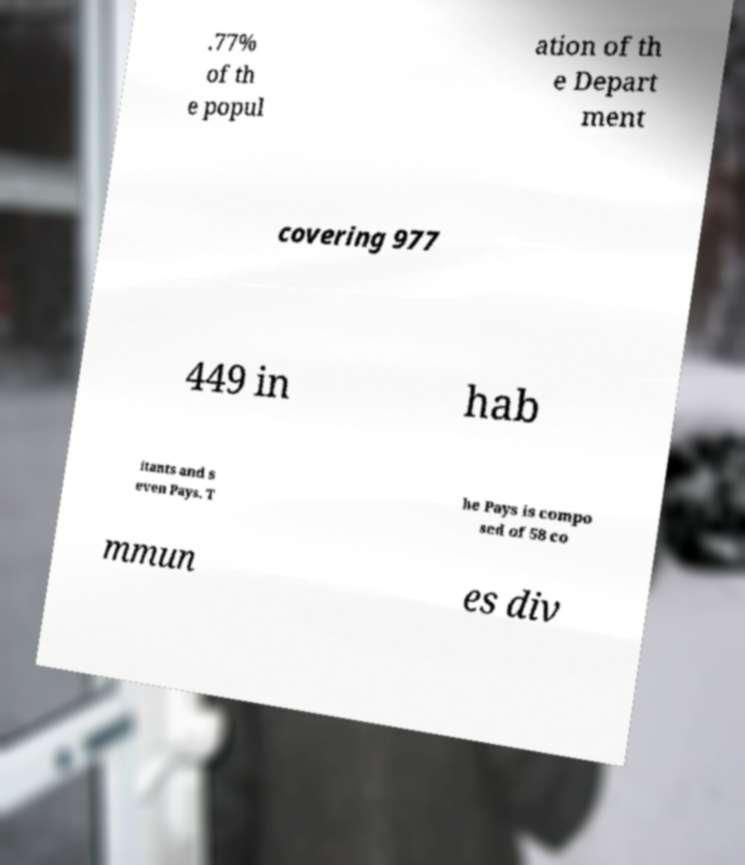Can you accurately transcribe the text from the provided image for me? .77% of th e popul ation of th e Depart ment covering 977 449 in hab itants and s even Pays. T he Pays is compo sed of 58 co mmun es div 